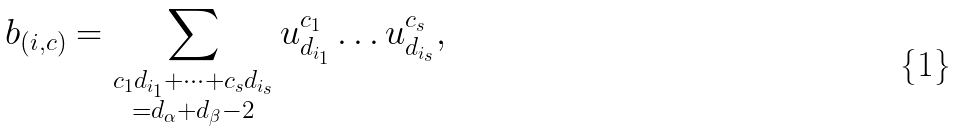<formula> <loc_0><loc_0><loc_500><loc_500>b _ { ( i , c ) } = \sum _ { \substack { c _ { 1 } d _ { i _ { 1 } } + \dots + c _ { s } d _ { i _ { s } } \\ = d _ { \alpha } + d _ { \beta } - 2 } } u _ { d _ { i _ { 1 } } } ^ { c _ { 1 } } \dots u _ { d _ { i _ { s } } } ^ { c _ { s } } ,</formula> 